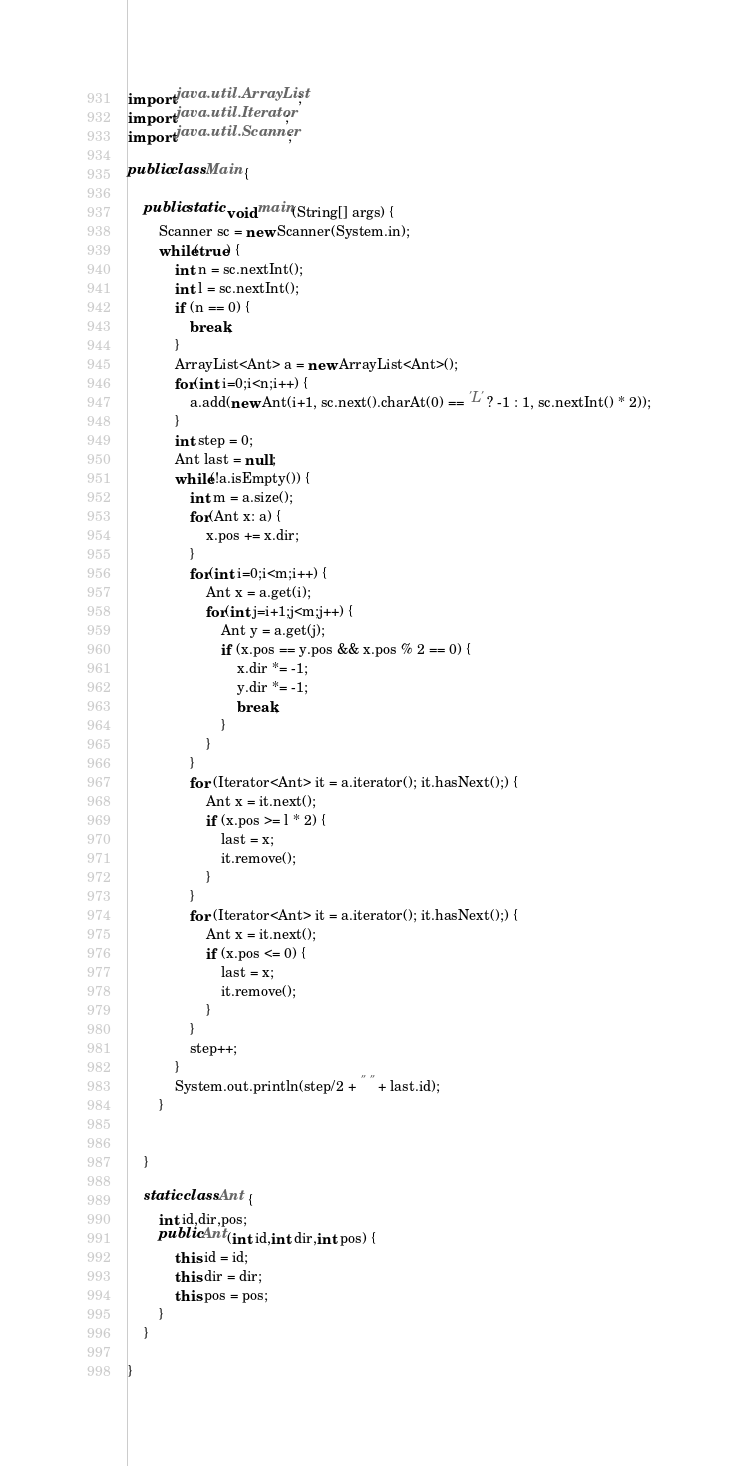Convert code to text. <code><loc_0><loc_0><loc_500><loc_500><_Java_>import java.util.ArrayList;
import java.util.Iterator;
import java.util.Scanner;

public class Main {

	public static void main(String[] args) {
		Scanner sc = new Scanner(System.in);
		while(true) {
			int n = sc.nextInt();
			int l = sc.nextInt();
			if (n == 0) {
				break;
			}
			ArrayList<Ant> a = new ArrayList<Ant>();
			for(int i=0;i<n;i++) {
				a.add(new Ant(i+1, sc.next().charAt(0) == 'L' ? -1 : 1, sc.nextInt() * 2)); 
			}
			int step = 0;
			Ant last = null;
			while(!a.isEmpty()) {
				int m = a.size();
				for(Ant x: a) {
					x.pos += x.dir;
				}
				for(int i=0;i<m;i++) {
					Ant x = a.get(i);
					for(int j=i+1;j<m;j++) {
						Ant y = a.get(j);
						if (x.pos == y.pos && x.pos % 2 == 0) {
							x.dir *= -1;
							y.dir *= -1;
							break;
						}
					}
				}
				for (Iterator<Ant> it = a.iterator(); it.hasNext();) {
					Ant x = it.next();
					if (x.pos >= l * 2) {
						last = x;
						it.remove();
					}
				}
				for (Iterator<Ant> it = a.iterator(); it.hasNext();) {
					Ant x = it.next();
					if (x.pos <= 0) {
						last = x;
						it.remove();
					}
				}
				step++;
			}
			System.out.println(step/2 + " " + last.id);
		}

		
	}
	
	static class Ant {
		int id,dir,pos;
		public Ant(int id,int dir,int pos) {
			this.id = id;
			this.dir = dir;
			this.pos = pos;
		}
	}

}</code> 